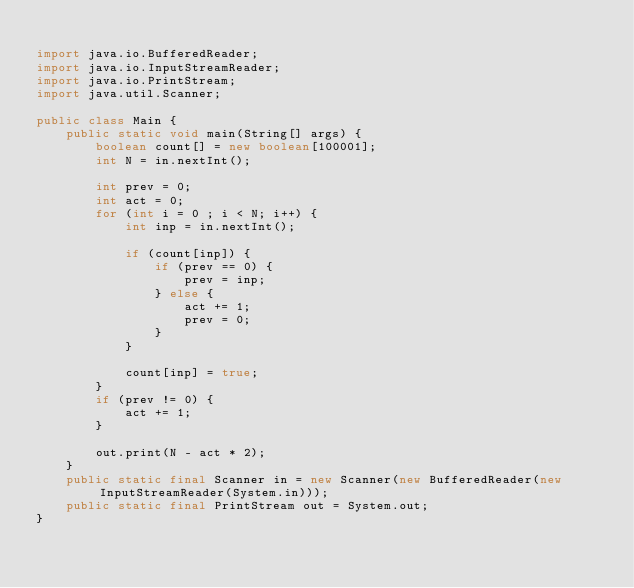Convert code to text. <code><loc_0><loc_0><loc_500><loc_500><_Java_>
import java.io.BufferedReader;
import java.io.InputStreamReader;
import java.io.PrintStream;
import java.util.Scanner;

public class Main {
    public static void main(String[] args) {
        boolean count[] = new boolean[100001];
        int N = in.nextInt();

        int prev = 0;
        int act = 0;
        for (int i = 0 ; i < N; i++) {
            int inp = in.nextInt();

            if (count[inp]) {
                if (prev == 0) {
                    prev = inp;
                } else {
                    act += 1;
                    prev = 0;
                }
            }

            count[inp] = true;
        }
        if (prev != 0) {
            act += 1;
        }

        out.print(N - act * 2);
    }
    public static final Scanner in = new Scanner(new BufferedReader(new InputStreamReader(System.in)));
    public static final PrintStream out = System.out;
}
</code> 